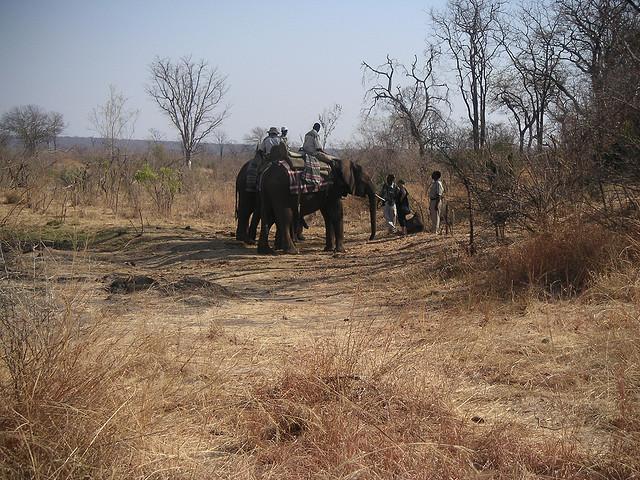Why is there a saddle on the elephant?
From the following four choices, select the correct answer to address the question.
Options: As decoration, to ride, to buy, to sell. To ride. 